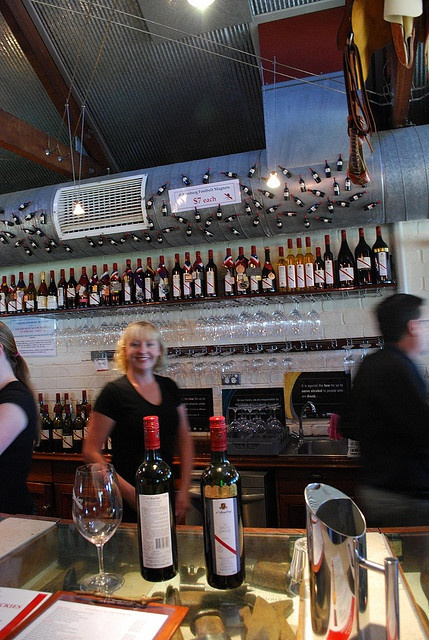Describe the objects in this image and their specific colors. I can see bottle in black, gray, darkgray, and maroon tones, people in black, darkgray, gray, and maroon tones, wine glass in black, darkgray, and gray tones, people in black, maroon, brown, and gray tones, and people in black, darkgray, gray, and maroon tones in this image. 